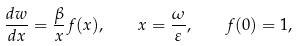Convert formula to latex. <formula><loc_0><loc_0><loc_500><loc_500>\frac { d w } { d x } = \frac { \beta } { x } f ( x ) , \quad x = \frac { \omega } { \varepsilon } , \quad f ( 0 ) = 1 ,</formula> 